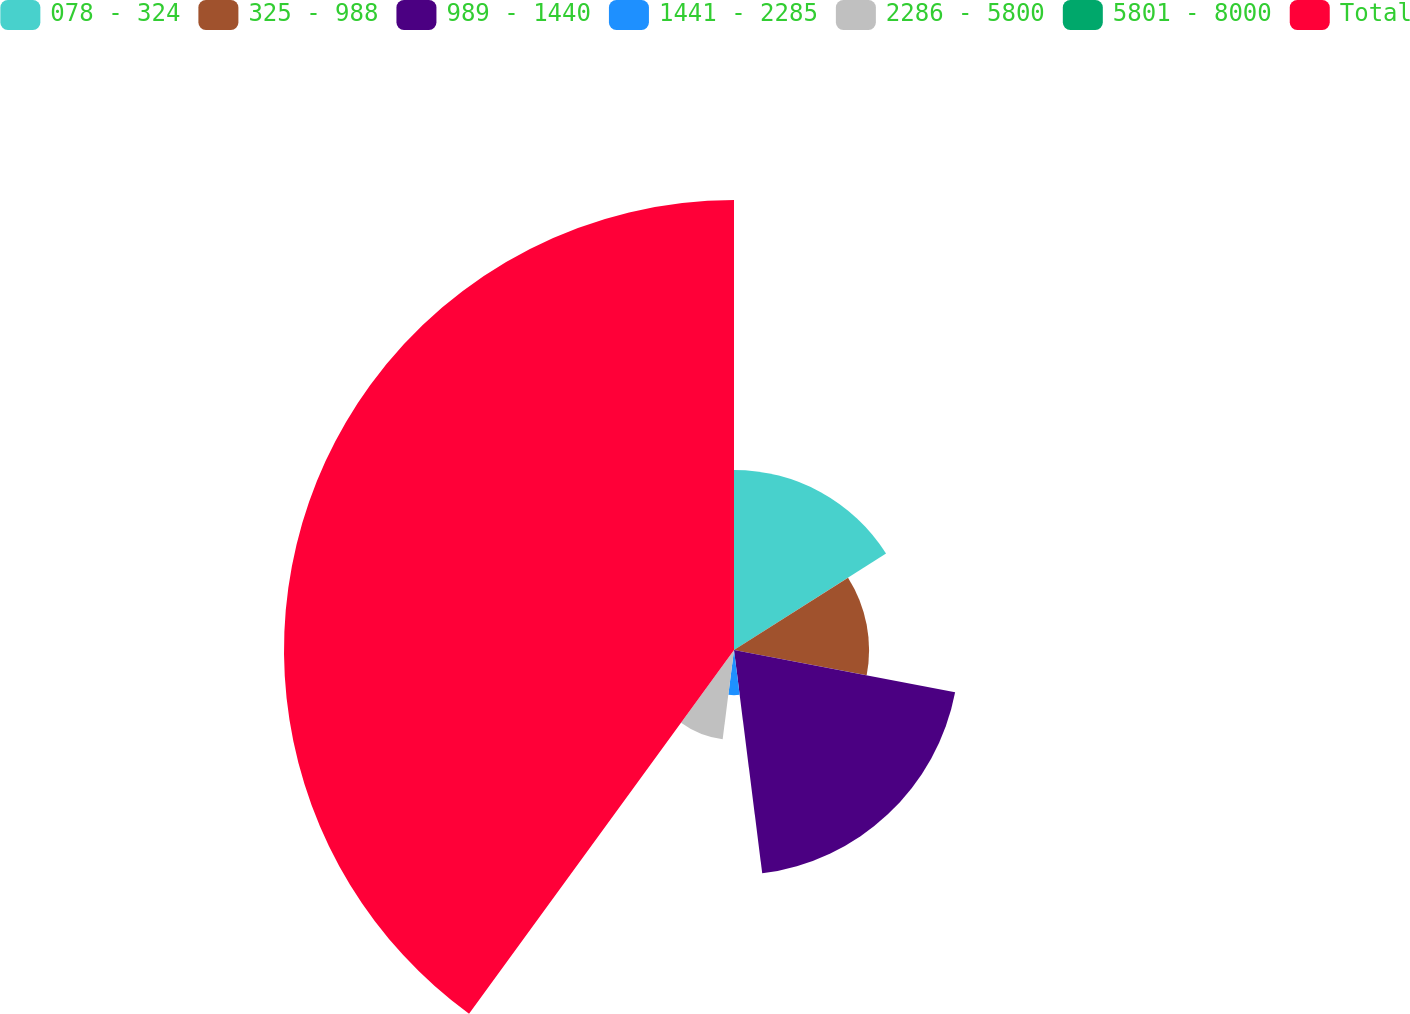Convert chart. <chart><loc_0><loc_0><loc_500><loc_500><pie_chart><fcel>078 - 324<fcel>325 - 988<fcel>989 - 1440<fcel>1441 - 2285<fcel>2286 - 5800<fcel>5801 - 8000<fcel>Total<nl><fcel>16.0%<fcel>12.0%<fcel>20.0%<fcel>4.01%<fcel>8.0%<fcel>0.01%<fcel>39.98%<nl></chart> 